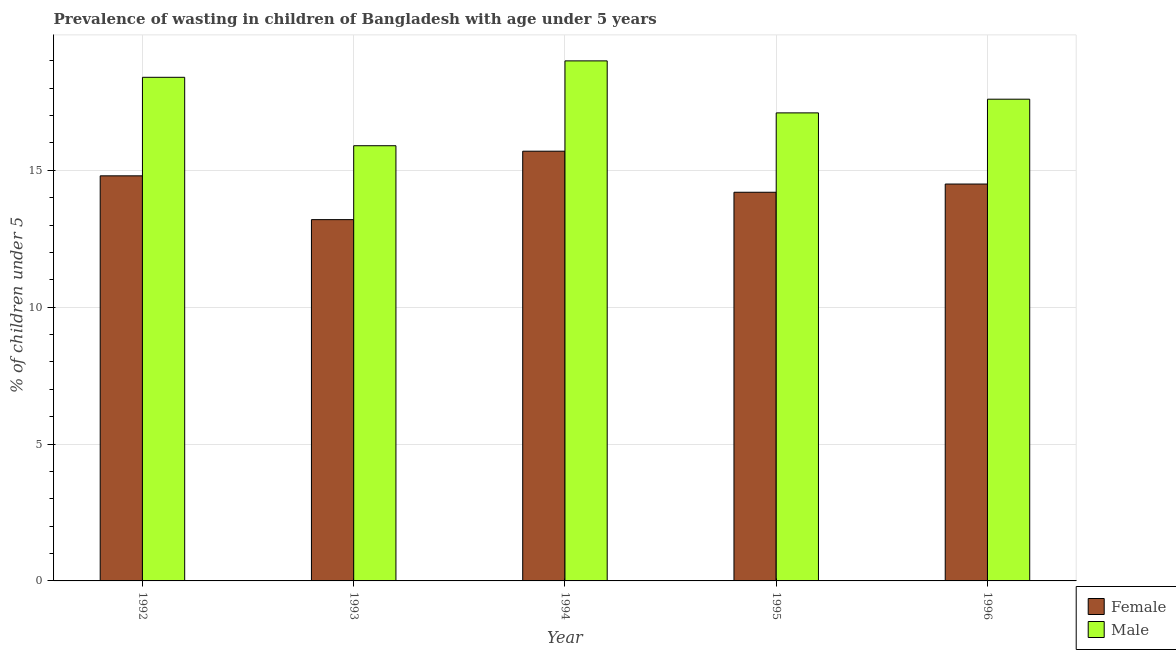How many different coloured bars are there?
Make the answer very short. 2. Are the number of bars per tick equal to the number of legend labels?
Your answer should be very brief. Yes. Are the number of bars on each tick of the X-axis equal?
Ensure brevity in your answer.  Yes. How many bars are there on the 4th tick from the right?
Offer a very short reply. 2. What is the percentage of undernourished female children in 1995?
Ensure brevity in your answer.  14.2. Across all years, what is the maximum percentage of undernourished female children?
Offer a terse response. 15.7. Across all years, what is the minimum percentage of undernourished female children?
Give a very brief answer. 13.2. What is the total percentage of undernourished male children in the graph?
Keep it short and to the point. 88. What is the difference between the percentage of undernourished female children in 1995 and that in 1996?
Ensure brevity in your answer.  -0.3. What is the difference between the percentage of undernourished female children in 1995 and the percentage of undernourished male children in 1993?
Your answer should be very brief. 1. What is the average percentage of undernourished female children per year?
Provide a short and direct response. 14.48. In the year 1994, what is the difference between the percentage of undernourished male children and percentage of undernourished female children?
Provide a succinct answer. 0. In how many years, is the percentage of undernourished male children greater than 7 %?
Ensure brevity in your answer.  5. What is the ratio of the percentage of undernourished male children in 1994 to that in 1995?
Your response must be concise. 1.11. What is the difference between the highest and the second highest percentage of undernourished male children?
Ensure brevity in your answer.  0.6. What is the difference between the highest and the lowest percentage of undernourished male children?
Your answer should be very brief. 3.1. In how many years, is the percentage of undernourished female children greater than the average percentage of undernourished female children taken over all years?
Make the answer very short. 3. Are all the bars in the graph horizontal?
Offer a very short reply. No. How many years are there in the graph?
Provide a short and direct response. 5. How are the legend labels stacked?
Ensure brevity in your answer.  Vertical. What is the title of the graph?
Your response must be concise. Prevalence of wasting in children of Bangladesh with age under 5 years. What is the label or title of the X-axis?
Provide a short and direct response. Year. What is the label or title of the Y-axis?
Your answer should be very brief.  % of children under 5. What is the  % of children under 5 in Female in 1992?
Provide a short and direct response. 14.8. What is the  % of children under 5 in Male in 1992?
Offer a terse response. 18.4. What is the  % of children under 5 in Female in 1993?
Offer a very short reply. 13.2. What is the  % of children under 5 in Male in 1993?
Give a very brief answer. 15.9. What is the  % of children under 5 in Female in 1994?
Give a very brief answer. 15.7. What is the  % of children under 5 of Male in 1994?
Provide a succinct answer. 19. What is the  % of children under 5 in Female in 1995?
Make the answer very short. 14.2. What is the  % of children under 5 in Male in 1995?
Offer a very short reply. 17.1. What is the  % of children under 5 of Female in 1996?
Offer a very short reply. 14.5. What is the  % of children under 5 in Male in 1996?
Give a very brief answer. 17.6. Across all years, what is the maximum  % of children under 5 of Female?
Provide a succinct answer. 15.7. Across all years, what is the minimum  % of children under 5 in Female?
Give a very brief answer. 13.2. Across all years, what is the minimum  % of children under 5 in Male?
Keep it short and to the point. 15.9. What is the total  % of children under 5 of Female in the graph?
Provide a short and direct response. 72.4. What is the total  % of children under 5 in Male in the graph?
Offer a very short reply. 88. What is the difference between the  % of children under 5 of Female in 1992 and that in 1993?
Give a very brief answer. 1.6. What is the difference between the  % of children under 5 in Male in 1992 and that in 1995?
Your answer should be compact. 1.3. What is the difference between the  % of children under 5 of Male in 1992 and that in 1996?
Provide a succinct answer. 0.8. What is the difference between the  % of children under 5 of Male in 1993 and that in 1994?
Make the answer very short. -3.1. What is the difference between the  % of children under 5 of Male in 1993 and that in 1996?
Keep it short and to the point. -1.7. What is the difference between the  % of children under 5 in Male in 1995 and that in 1996?
Provide a short and direct response. -0.5. What is the difference between the  % of children under 5 of Female in 1992 and the  % of children under 5 of Male in 1994?
Offer a terse response. -4.2. What is the difference between the  % of children under 5 of Female in 1992 and the  % of children under 5 of Male in 1995?
Provide a short and direct response. -2.3. What is the difference between the  % of children under 5 of Female in 1992 and the  % of children under 5 of Male in 1996?
Ensure brevity in your answer.  -2.8. What is the difference between the  % of children under 5 of Female in 1994 and the  % of children under 5 of Male in 1995?
Provide a succinct answer. -1.4. What is the difference between the  % of children under 5 in Female in 1994 and the  % of children under 5 in Male in 1996?
Give a very brief answer. -1.9. What is the average  % of children under 5 of Female per year?
Ensure brevity in your answer.  14.48. What is the average  % of children under 5 in Male per year?
Provide a succinct answer. 17.6. In the year 1994, what is the difference between the  % of children under 5 of Female and  % of children under 5 of Male?
Offer a very short reply. -3.3. In the year 1996, what is the difference between the  % of children under 5 of Female and  % of children under 5 of Male?
Keep it short and to the point. -3.1. What is the ratio of the  % of children under 5 of Female in 1992 to that in 1993?
Make the answer very short. 1.12. What is the ratio of the  % of children under 5 in Male in 1992 to that in 1993?
Offer a very short reply. 1.16. What is the ratio of the  % of children under 5 in Female in 1992 to that in 1994?
Offer a very short reply. 0.94. What is the ratio of the  % of children under 5 in Male in 1992 to that in 1994?
Give a very brief answer. 0.97. What is the ratio of the  % of children under 5 of Female in 1992 to that in 1995?
Make the answer very short. 1.04. What is the ratio of the  % of children under 5 of Male in 1992 to that in 1995?
Offer a very short reply. 1.08. What is the ratio of the  % of children under 5 of Female in 1992 to that in 1996?
Your answer should be very brief. 1.02. What is the ratio of the  % of children under 5 of Male in 1992 to that in 1996?
Provide a short and direct response. 1.05. What is the ratio of the  % of children under 5 in Female in 1993 to that in 1994?
Offer a terse response. 0.84. What is the ratio of the  % of children under 5 in Male in 1993 to that in 1994?
Offer a terse response. 0.84. What is the ratio of the  % of children under 5 in Female in 1993 to that in 1995?
Ensure brevity in your answer.  0.93. What is the ratio of the  % of children under 5 in Male in 1993 to that in 1995?
Give a very brief answer. 0.93. What is the ratio of the  % of children under 5 in Female in 1993 to that in 1996?
Your response must be concise. 0.91. What is the ratio of the  % of children under 5 in Male in 1993 to that in 1996?
Provide a succinct answer. 0.9. What is the ratio of the  % of children under 5 in Female in 1994 to that in 1995?
Provide a short and direct response. 1.11. What is the ratio of the  % of children under 5 in Female in 1994 to that in 1996?
Your answer should be compact. 1.08. What is the ratio of the  % of children under 5 of Male in 1994 to that in 1996?
Your answer should be compact. 1.08. What is the ratio of the  % of children under 5 in Female in 1995 to that in 1996?
Keep it short and to the point. 0.98. What is the ratio of the  % of children under 5 in Male in 1995 to that in 1996?
Make the answer very short. 0.97. What is the difference between the highest and the second highest  % of children under 5 in Male?
Keep it short and to the point. 0.6. What is the difference between the highest and the lowest  % of children under 5 in Female?
Keep it short and to the point. 2.5. What is the difference between the highest and the lowest  % of children under 5 in Male?
Provide a short and direct response. 3.1. 